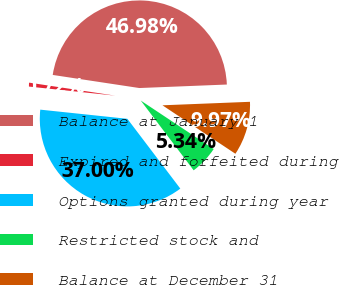Convert chart to OTSL. <chart><loc_0><loc_0><loc_500><loc_500><pie_chart><fcel>Balance at January 1<fcel>Expired and forfeited during<fcel>Options granted during year<fcel>Restricted stock and<fcel>Balance at December 31<nl><fcel>46.98%<fcel>0.72%<fcel>37.0%<fcel>5.34%<fcel>9.97%<nl></chart> 